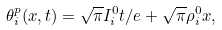<formula> <loc_0><loc_0><loc_500><loc_500>\theta _ { i } ^ { p } ( x , t ) = \sqrt { \pi } I ^ { 0 } _ { i } t / e + \sqrt { \pi } \rho ^ { 0 } _ { i } x ,</formula> 